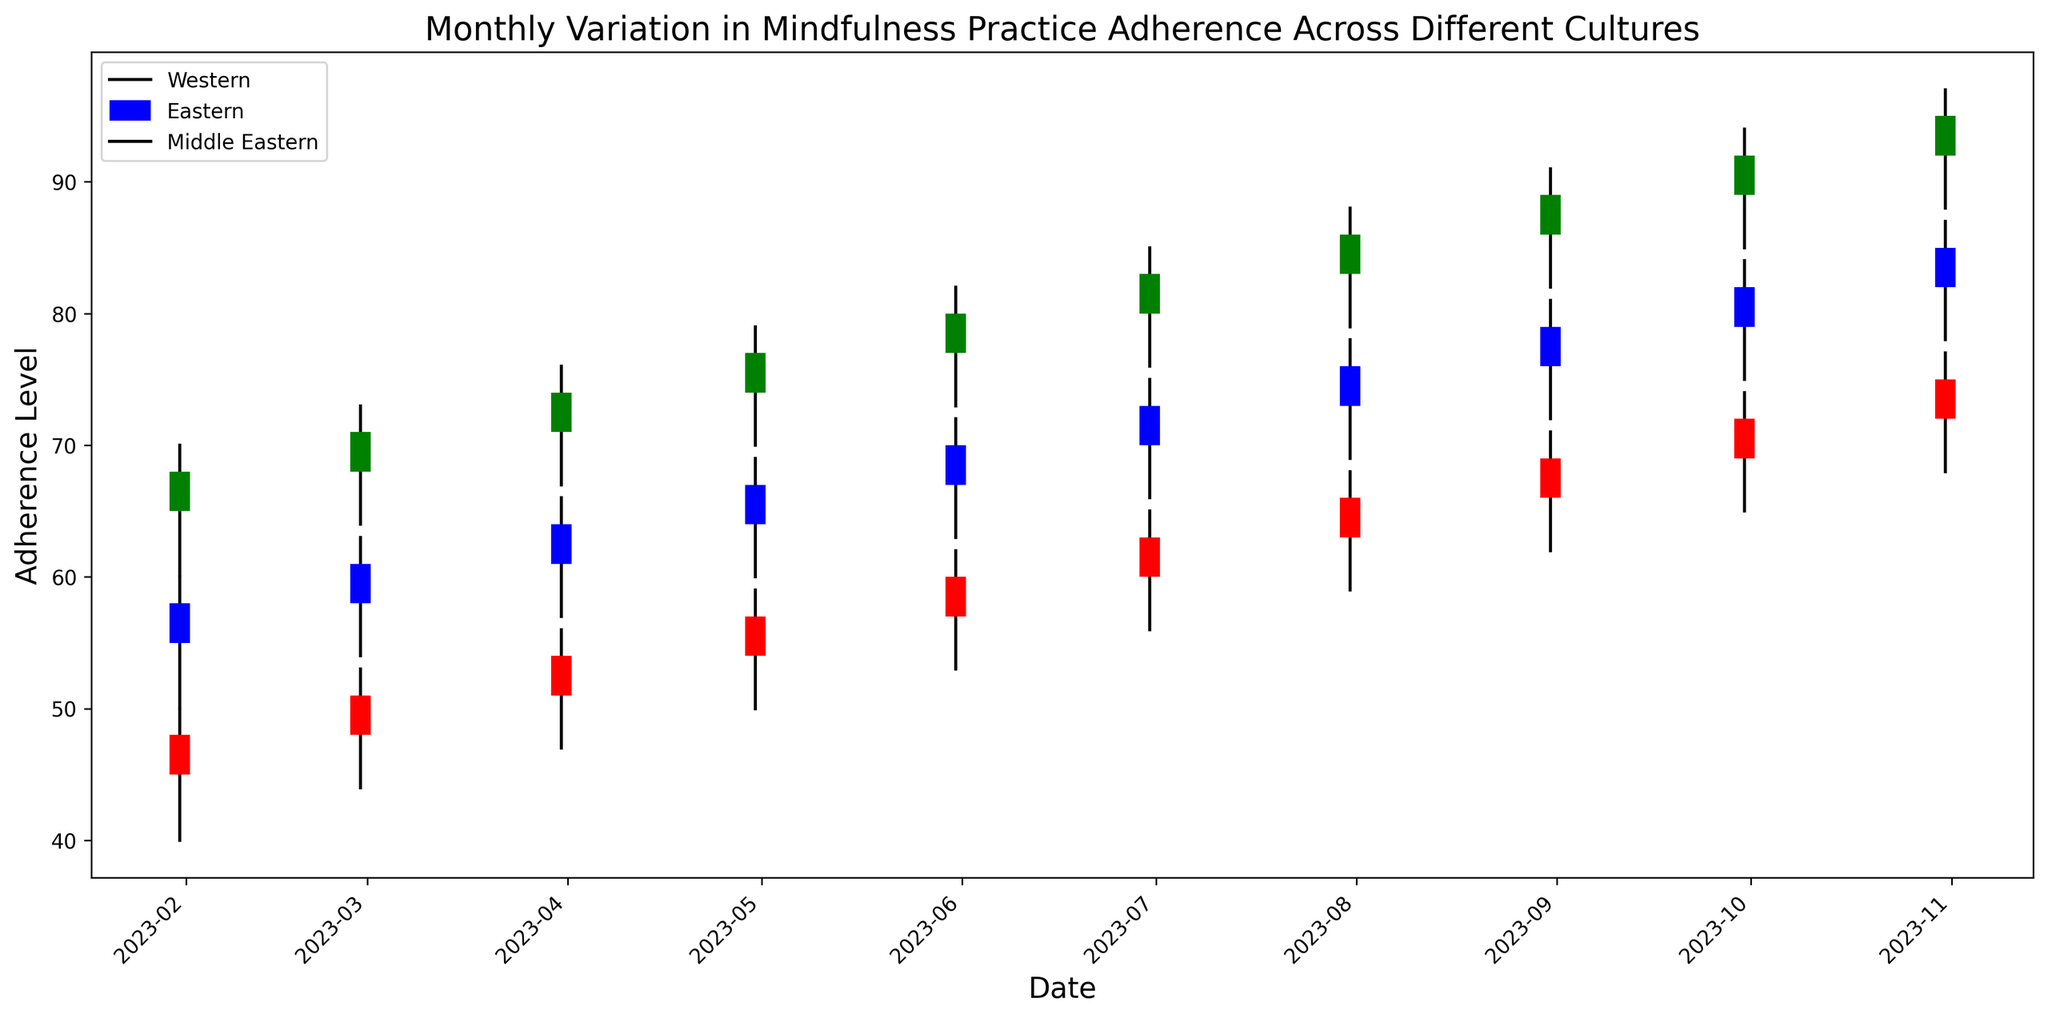Which culture showed the highest mindfulness practice adherence in October 2023? Observe the closing values for October 2023. The highest adherence is represented by the highest closing value. The Eastern culture has the highest closing value of 95.
Answer: The Eastern culture How did the adherence level of the Middle Eastern culture change from January 2023 to October 2023? Check the closing value for the Middle Eastern culture in January 2023 (48) and in October 2023 (75). The adherence increased as 48 to 75.
Answer: Increased Which culture has shown the most consistent increase in adherence levels throughout 2023? Examine the trend of closing values month-by-month for each culture. The Eastern culture consistently increases adherence with no decreases.
Answer: The Eastern culture What is the difference between the highest and lowest adherence levels for the Western culture in 2023? The highest closing value for the Western culture is 85 (October 2023), and the lowest is 58 (January 2023). The difference is 85 - 58 = 27.
Answer: 27 Compare the adherence levels of Western and Middle Eastern cultures in July 2023. Which one is higher? For July 2023, compare the closing values: Western (76) and Middle Eastern (66). The Western culture has a higher value.
Answer: The Western culture What was the average adherence level for the Eastern culture during the second quarter of 2023 (April - June)? The closing values for April 2023, May 2023, and June 2023 are 77, 80, and 83 respectively. The average is (77 + 80 + 83) / 3 = 80.
Answer: 80 During which month did the Middle Eastern culture experience the highest increase in adherence? Calculate the monthly differences in adherence for the Middle Eastern culture and identify the month with the highest increase. From June to July, the increase is the highest: 66 - 63 = 3.
Answer: July 2023 How do the highest and lowest adherence levels of the Western culture in the second half of 2023 compare? Identify the highest (85 in October) and lowest (73 in June) closing values for the Western culture from July to October. Compare them and the highest is always greater than the lowest.
Answer: Higher When comparing the adherence levels in February 2023 between the Eastern and the Western cultures, which one was higher and by how much? The closing values for February 2023 are Eastern: 71, Western: 61. The difference is 71 - 61 = 10. The Eastern culture is higher by 10.
Answer: Eastern by 10 Which culture’s adherence levels show the greatest range (difference between highest and lowest) over the entire 2023 period? Find the difference between the highest and lowest closing values for each culture. The Eastern culture has the greatest range (95 - 68 = 27).
Answer: The Eastern culture 